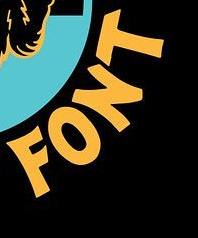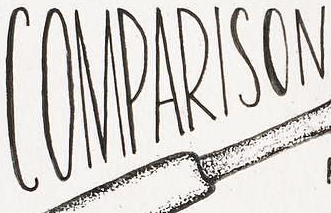What words are shown in these images in order, separated by a semicolon? FONT; COMPARISON 